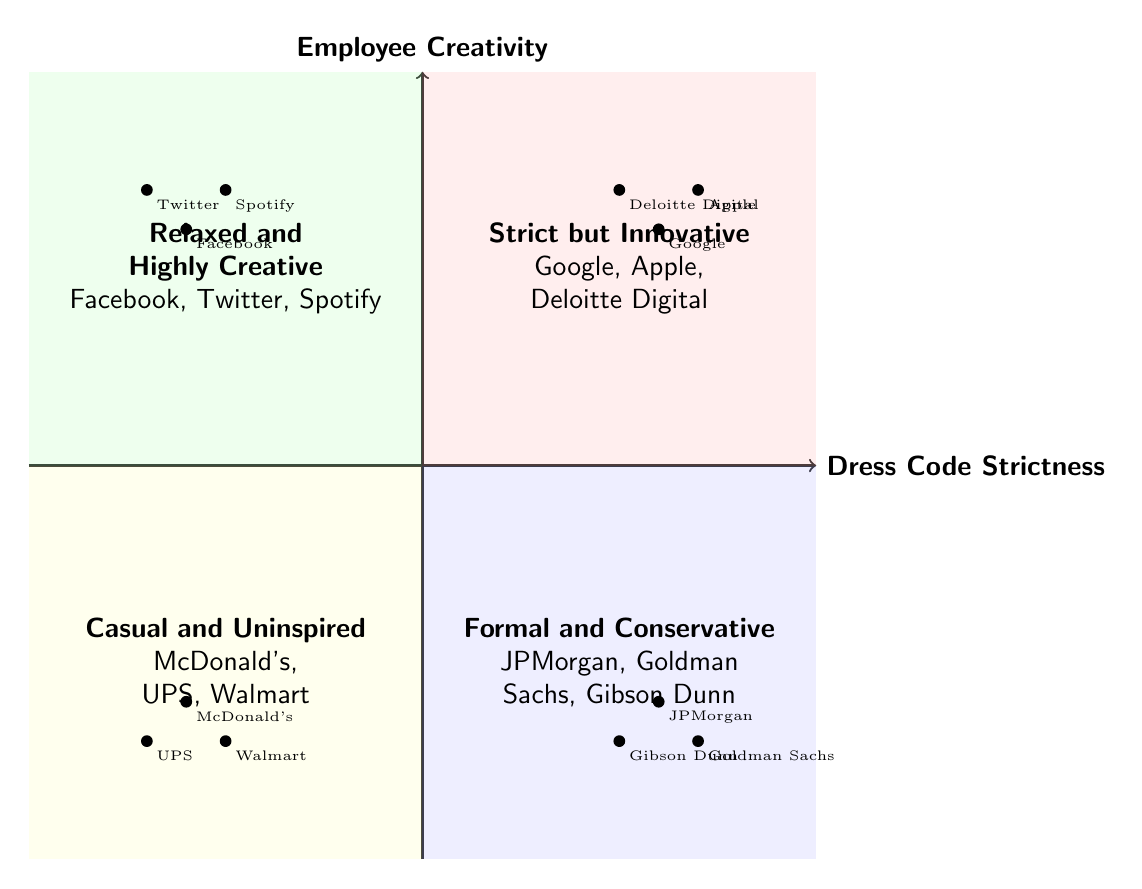What are the two companies in the "Relaxed and Highly Creative" quadrant? The "Relaxed and Highly Creative" quadrant contains Facebook and Twitter as examples. These companies are positioned in the quadrant indicating low strictness and high creativity.
Answer: Facebook, Twitter How many companies are listed in the "Formal and Conservative" quadrant? The "Formal and Conservative" quadrant has three companies listed: JPMorgan, Goldman Sachs, and Gibson Dunn. Therefore, the count of companies in this quadrant is three.
Answer: Three What characterizes the "Strict but Innovative" quadrant? The "Strict but Innovative" quadrant is defined by high strictness in dress code, yet allowing for high employee creativity, exemplified by companies like Google and Apple.
Answer: High strictness, high creativity Which quadrant contains companies like McDonald's and UPS? McDonald's and UPS are examples found in the "Casual and Uninspired" quadrant, characterized by low strictness and low creativity in dress codes.
Answer: Casual and Uninspired How many quadrants are in the chart? The chart consists of four quadrants, each representing different combinations of dress code strictness and employee creativity.
Answer: Four 